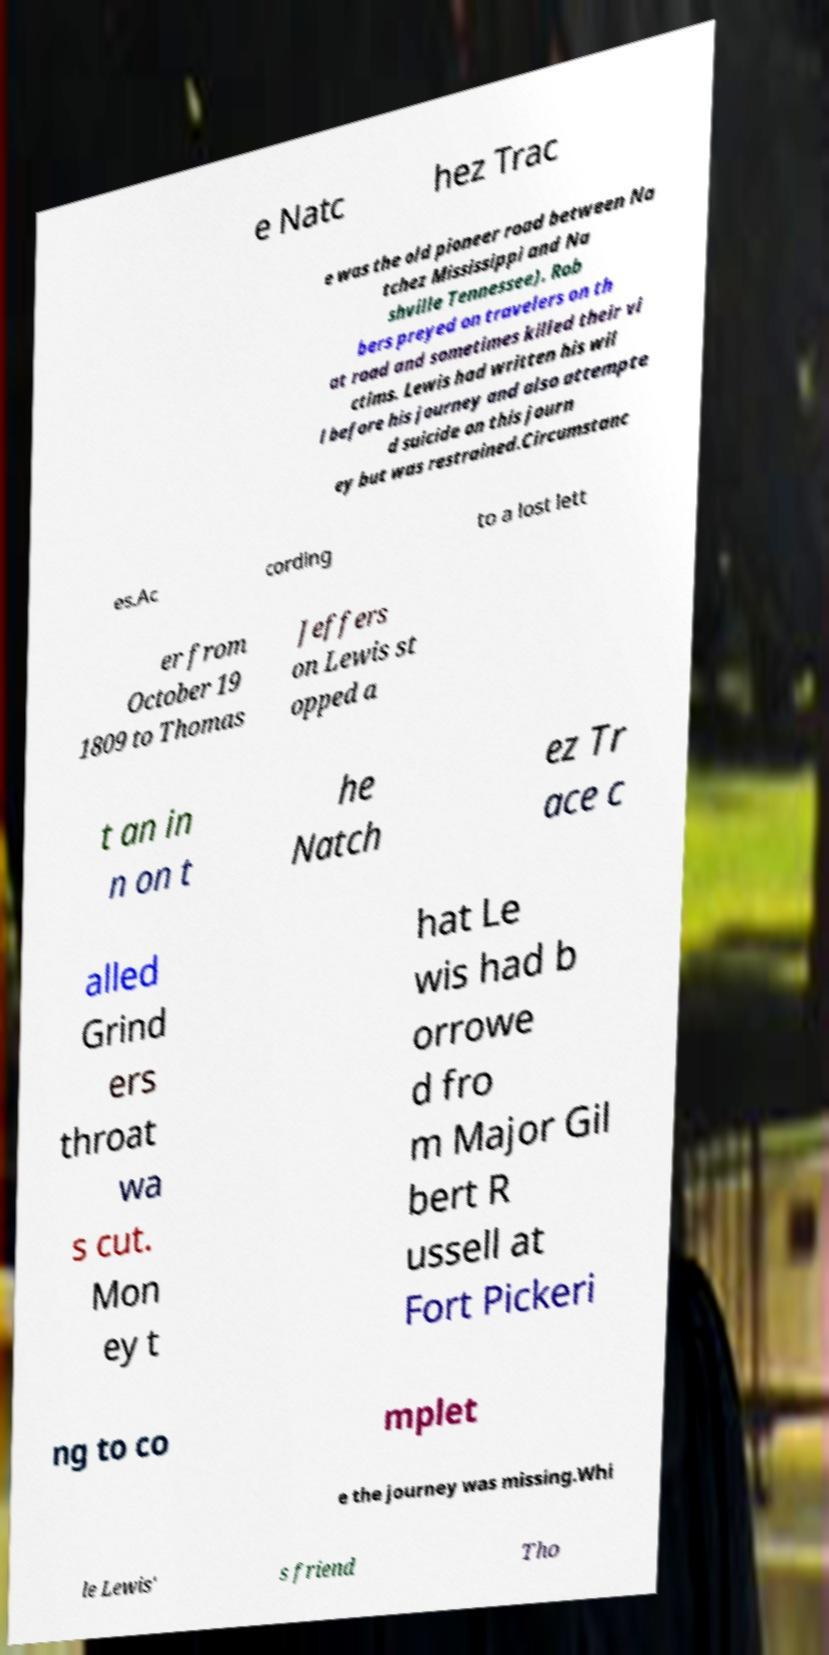Could you assist in decoding the text presented in this image and type it out clearly? e Natc hez Trac e was the old pioneer road between Na tchez Mississippi and Na shville Tennessee). Rob bers preyed on travelers on th at road and sometimes killed their vi ctims. Lewis had written his wil l before his journey and also attempte d suicide on this journ ey but was restrained.Circumstanc es.Ac cording to a lost lett er from October 19 1809 to Thomas Jeffers on Lewis st opped a t an in n on t he Natch ez Tr ace c alled Grind ers throat wa s cut. Mon ey t hat Le wis had b orrowe d fro m Major Gil bert R ussell at Fort Pickeri ng to co mplet e the journey was missing.Whi le Lewis' s friend Tho 